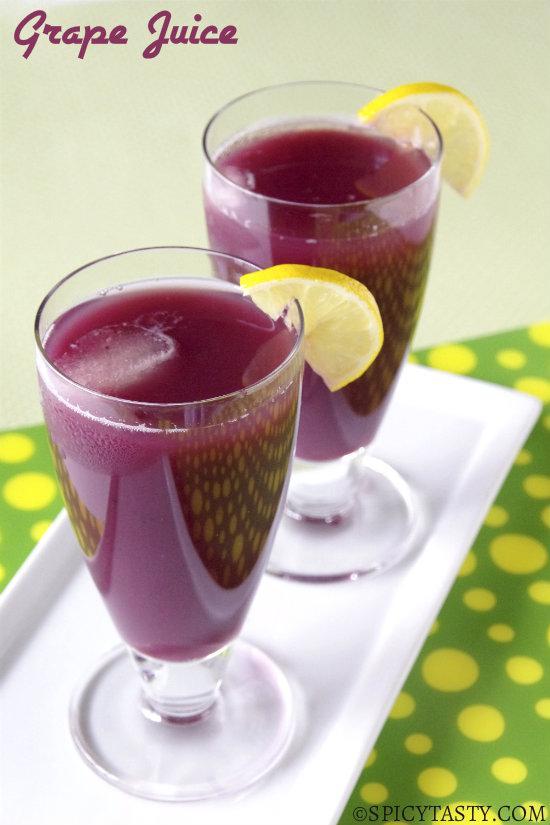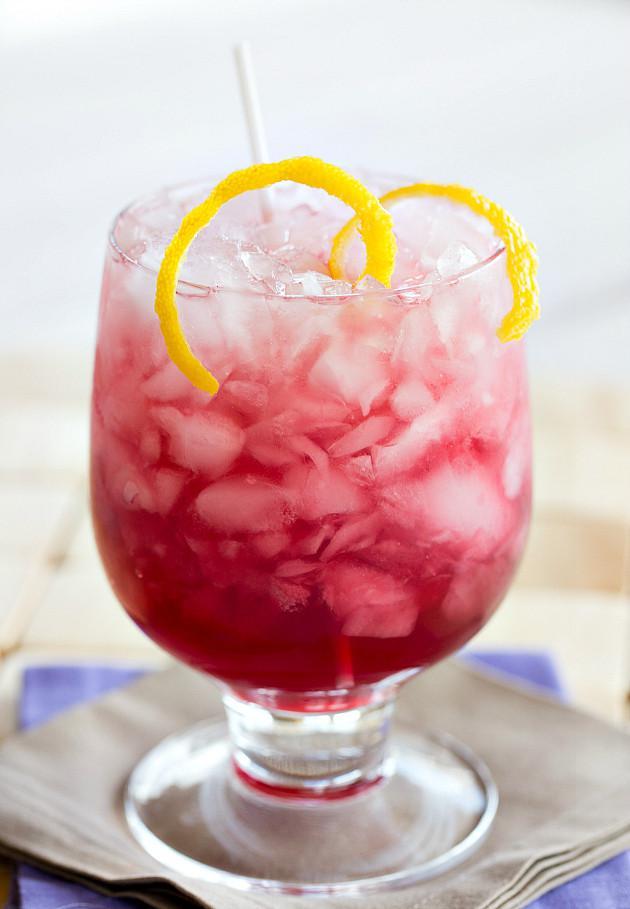The first image is the image on the left, the second image is the image on the right. For the images displayed, is the sentence "All of the images contain only one glass that is filled with a beverage." factually correct? Answer yes or no. No. 